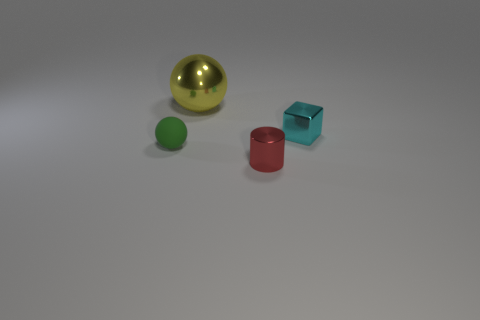Subtract all purple cylinders. Subtract all cyan blocks. How many cylinders are left? 1 Add 1 small cyan blocks. How many objects exist? 5 Subtract all cylinders. How many objects are left? 3 Subtract 1 yellow spheres. How many objects are left? 3 Subtract all green shiny cylinders. Subtract all small metal cylinders. How many objects are left? 3 Add 1 cyan cubes. How many cyan cubes are left? 2 Add 1 small matte balls. How many small matte balls exist? 2 